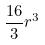Convert formula to latex. <formula><loc_0><loc_0><loc_500><loc_500>\frac { 1 6 } { 3 } r ^ { 3 }</formula> 